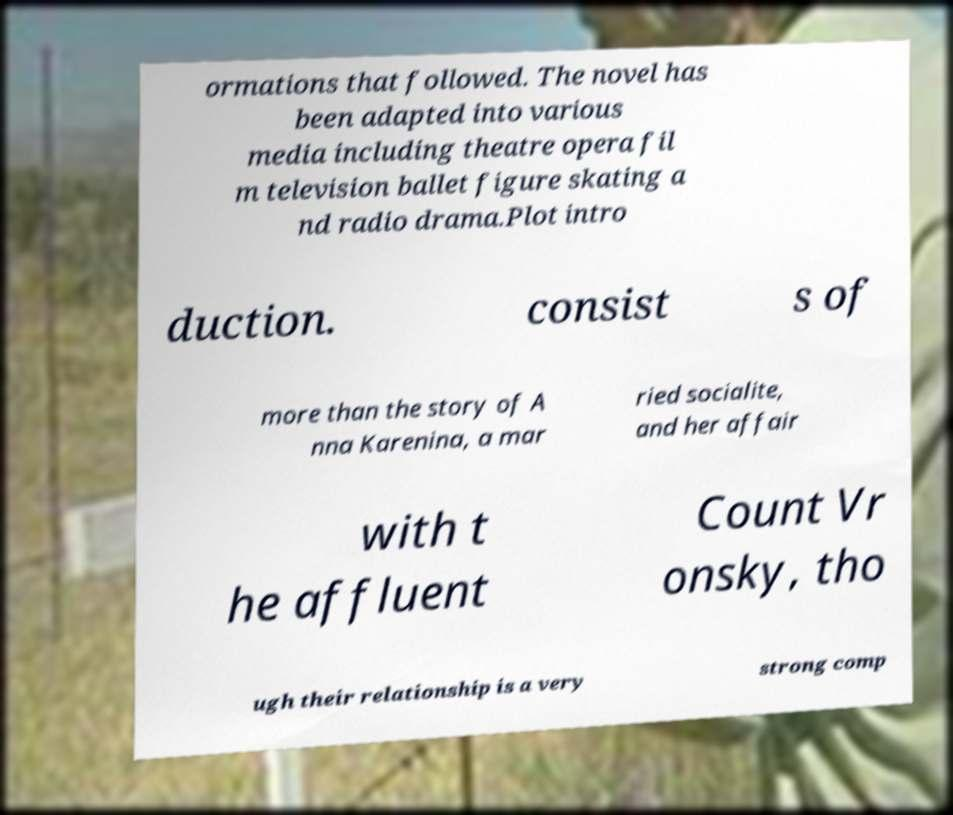Please identify and transcribe the text found in this image. ormations that followed. The novel has been adapted into various media including theatre opera fil m television ballet figure skating a nd radio drama.Plot intro duction. consist s of more than the story of A nna Karenina, a mar ried socialite, and her affair with t he affluent Count Vr onsky, tho ugh their relationship is a very strong comp 